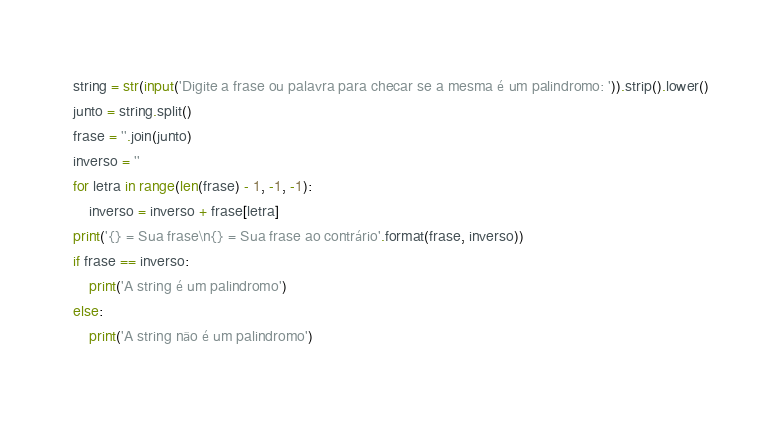<code> <loc_0><loc_0><loc_500><loc_500><_Python_>string = str(input('Digite a frase ou palavra para checar se a mesma é um palindromo: ')).strip().lower()
junto = string.split()
frase = ''.join(junto)
inverso = ''
for letra in range(len(frase) - 1, -1, -1):
    inverso = inverso + frase[letra]
print('{} = Sua frase\n{} = Sua frase ao contrário'.format(frase, inverso))
if frase == inverso:
    print('A string é um palindromo')
else:
    print('A string não é um palindromo')</code> 